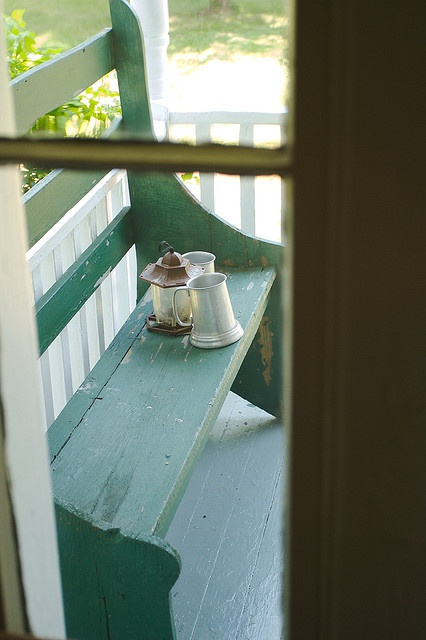Describe the objects in this image and their specific colors. I can see bench in beige, gray, darkgray, darkgreen, and lightgray tones, cup in beige, darkgray, ivory, and gray tones, and cup in beige, darkgray, ivory, and gray tones in this image. 